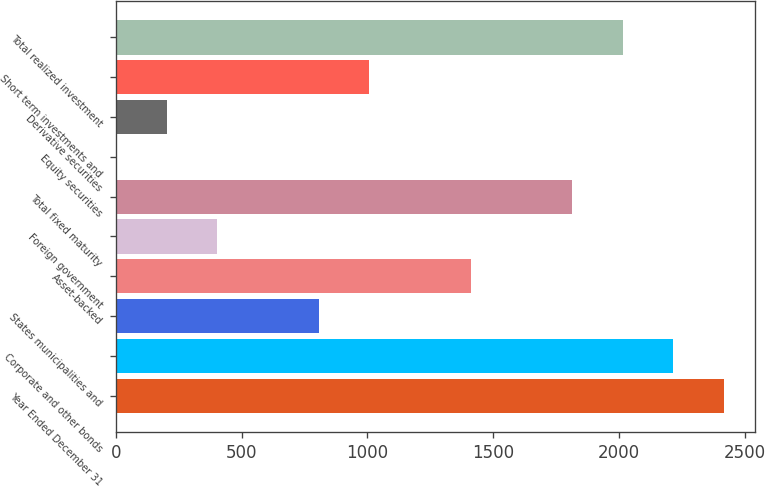Convert chart. <chart><loc_0><loc_0><loc_500><loc_500><bar_chart><fcel>Year Ended December 31<fcel>Corporate and other bonds<fcel>States municipalities and<fcel>Asset-backed<fcel>Foreign government<fcel>Total fixed maturity<fcel>Equity securities<fcel>Derivative securities<fcel>Short term investments and<fcel>Total realized investment<nl><fcel>2416.6<fcel>2215.3<fcel>806.2<fcel>1410.1<fcel>403.6<fcel>1812.7<fcel>1<fcel>202.3<fcel>1007.5<fcel>2014<nl></chart> 